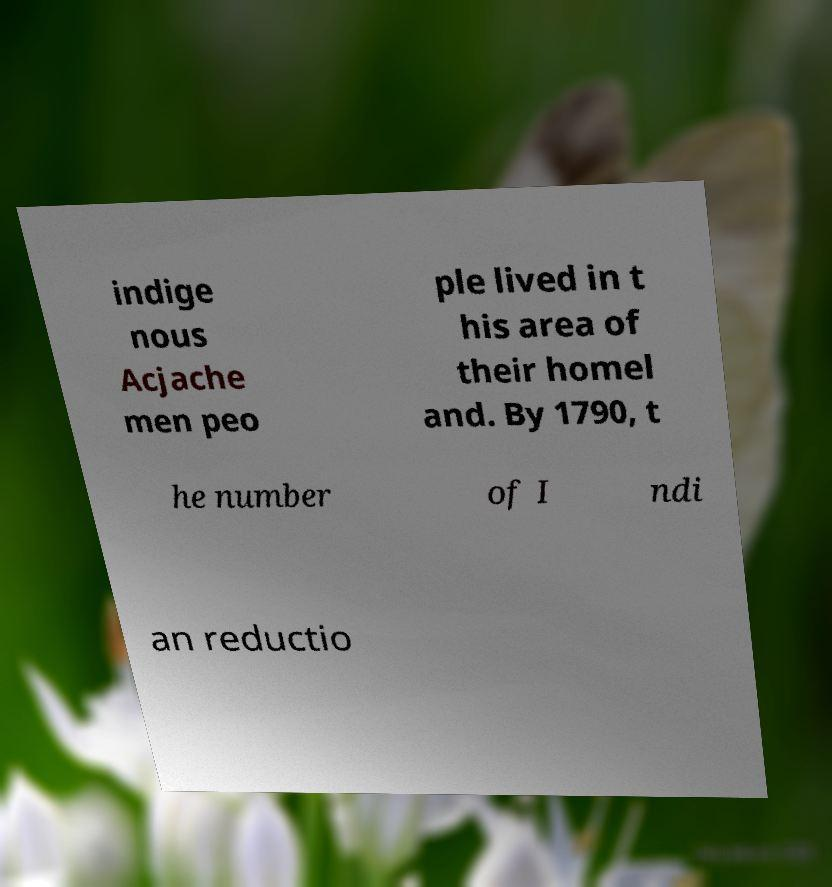There's text embedded in this image that I need extracted. Can you transcribe it verbatim? indige nous Acjache men peo ple lived in t his area of their homel and. By 1790, t he number of I ndi an reductio 